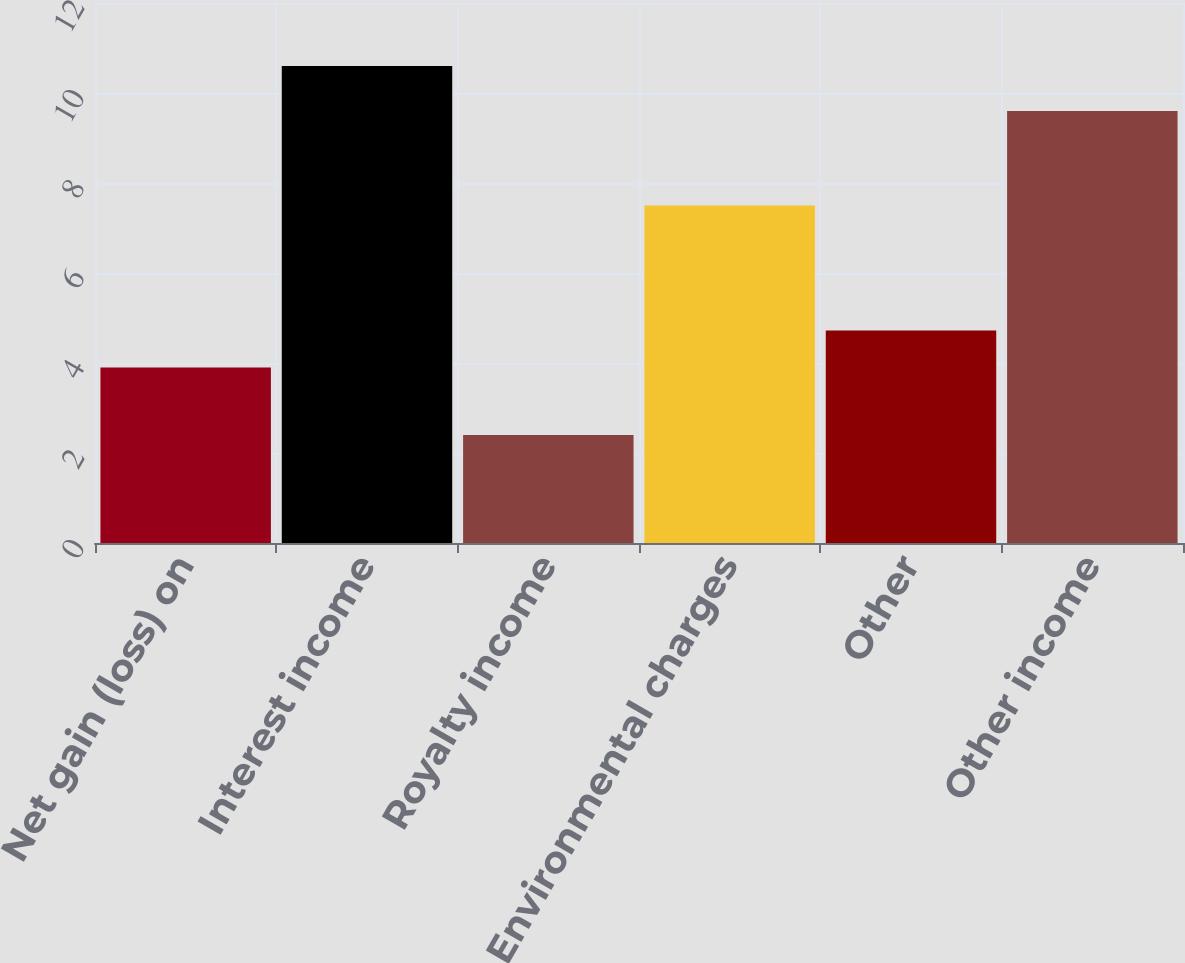<chart> <loc_0><loc_0><loc_500><loc_500><bar_chart><fcel>Net gain (loss) on<fcel>Interest income<fcel>Royalty income<fcel>Environmental charges<fcel>Other<fcel>Other income<nl><fcel>3.9<fcel>10.6<fcel>2.4<fcel>7.5<fcel>4.72<fcel>9.6<nl></chart> 